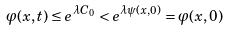<formula> <loc_0><loc_0><loc_500><loc_500>\varphi ( x , t ) \leq e ^ { \lambda C _ { 0 } } < e ^ { \lambda \psi ( x , 0 ) } = \varphi ( x , 0 )</formula> 